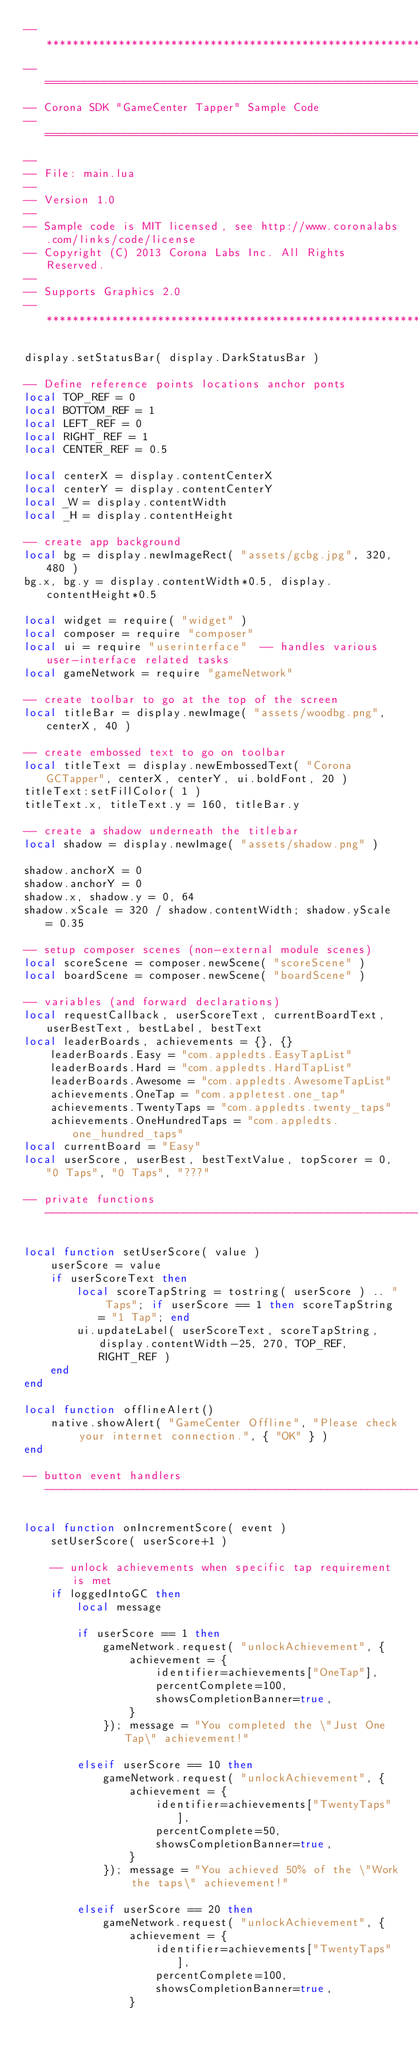Convert code to text. <code><loc_0><loc_0><loc_500><loc_500><_Lua_>--*********************************************************************************************
-- ====================================================================
-- Corona SDK "GameCenter Tapper" Sample Code
-- ====================================================================
--
-- File: main.lua
--
-- Version 1.0
--
-- Sample code is MIT licensed, see http://www.coronalabs.com/links/code/license
-- Copyright (C) 2013 Corona Labs Inc. All Rights Reserved.
--
-- Supports Graphics 2.0
--*********************************************************************************************

display.setStatusBar( display.DarkStatusBar )

-- Define reference points locations anchor ponts
local TOP_REF = 0
local BOTTOM_REF = 1
local LEFT_REF = 0
local RIGHT_REF = 1
local CENTER_REF = 0.5

local centerX = display.contentCenterX
local centerY = display.contentCenterY
local _W = display.contentWidth
local _H = display.contentHeight

-- create app background
local bg = display.newImageRect( "assets/gcbg.jpg", 320, 480 )
bg.x, bg.y = display.contentWidth*0.5, display.contentHeight*0.5

local widget = require( "widget" )
local composer = require "composer"
local ui = require "userinterface"	-- handles various user-interface related tasks
local gameNetwork = require "gameNetwork"

-- create toolbar to go at the top of the screen
local titleBar = display.newImage( "assets/woodbg.png", centerX, 40 )

-- create embossed text to go on toolbar
local titleText = display.newEmbossedText( "Corona GCTapper", centerX, centerY, ui.boldFont, 20 )
titleText:setFillColor( 1 )
titleText.x, titleText.y = 160, titleBar.y

-- create a shadow underneath the titlebar
local shadow = display.newImage( "assets/shadow.png" )

shadow.anchorX = 0
shadow.anchorY = 0
shadow.x, shadow.y = 0, 64
shadow.xScale = 320 / shadow.contentWidth; shadow.yScale = 0.35

-- setup composer scenes (non-external module scenes)
local scoreScene = composer.newScene( "scoreScene" )
local boardScene = composer.newScene( "boardScene" )

-- variables (and forward declarations)
local requestCallback, userScoreText, currentBoardText, userBestText, bestLabel, bestText
local leaderBoards, achievements = {}, {}
	leaderBoards.Easy = "com.appledts.EasyTapList"
	leaderBoards.Hard = "com.appledts.HardTapList"
	leaderBoards.Awesome = "com.appledts.AwesomeTapList"
	achievements.OneTap = "com.appletest.one_tap"
	achievements.TwentyTaps = "com.appledts.twenty_taps"
	achievements.OneHundredTaps = "com.appledts.one_hundred_taps"
local currentBoard = "Easy"
local userScore, userBest, bestTextValue, topScorer = 0, "0 Taps", "0 Taps", "???"

-- private functions --------------------------------------------------------------------

local function setUserScore( value )
	userScore = value
	if userScoreText then
		local scoreTapString = tostring( userScore ) .. " Taps"; if userScore == 1 then scoreTapString = "1 Tap"; end
		ui.updateLabel( userScoreText, scoreTapString, display.contentWidth-25, 270, TOP_REF, RIGHT_REF )
	end
end

local function offlineAlert() 
	native.showAlert( "GameCenter Offline", "Please check your internet connection.", { "OK" } )
end

-- button event handlers ----------------------------------------------------------------

local function onIncrementScore( event )
	setUserScore( userScore+1 )
	
	-- unlock achievements when specific tap requirement is met
	if loggedIntoGC then
		local message
		
		if userScore == 1 then
			gameNetwork.request( "unlockAchievement", {
				achievement = {
					identifier=achievements["OneTap"],
					percentComplete=100,
					showsCompletionBanner=true,
				}
			}); message = "You completed the \"Just One Tap\" achievement!"
		
		elseif userScore == 10 then
			gameNetwork.request( "unlockAchievement", {
				achievement = {
					identifier=achievements["TwentyTaps"],
					percentComplete=50,
					showsCompletionBanner=true,
				}
			}); message = "You achieved 50% of the \"Work the taps\" achievement!"
		
		elseif userScore == 20 then
			gameNetwork.request( "unlockAchievement", {
				achievement = {
					identifier=achievements["TwentyTaps"],
					percentComplete=100,
					showsCompletionBanner=true,
				}</code> 